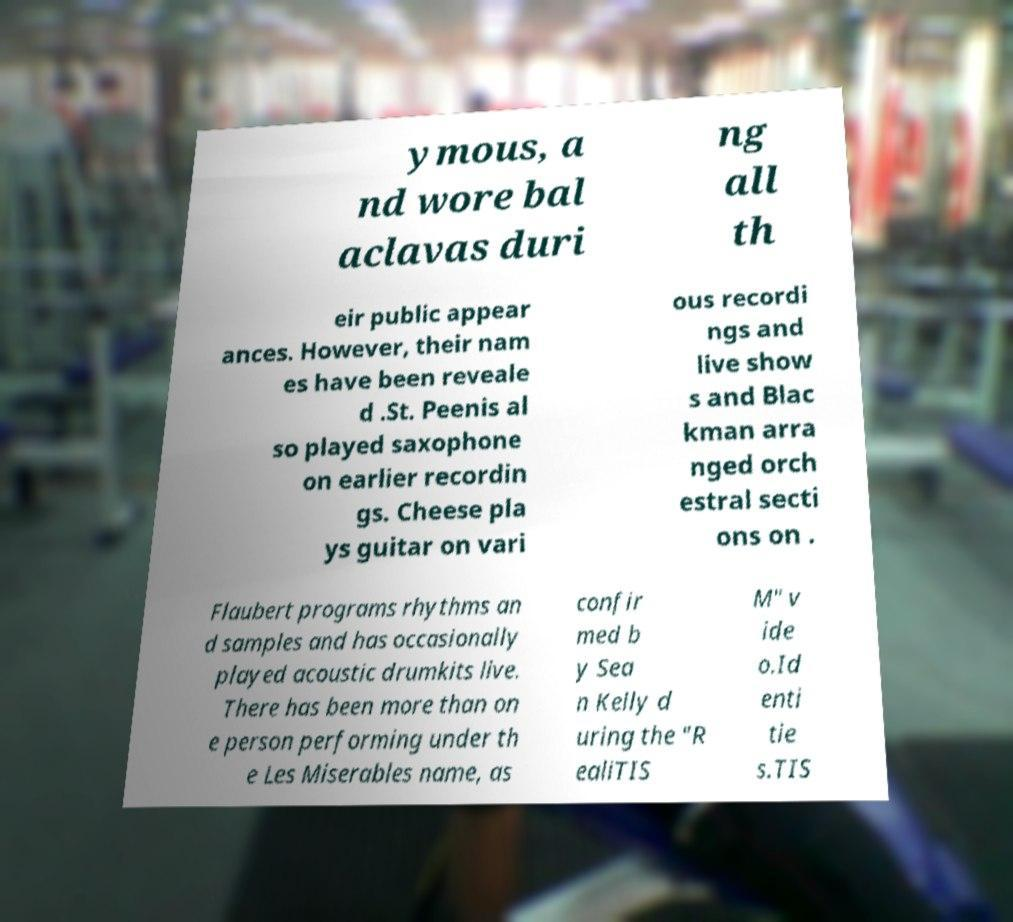What messages or text are displayed in this image? I need them in a readable, typed format. ymous, a nd wore bal aclavas duri ng all th eir public appear ances. However, their nam es have been reveale d .St. Peenis al so played saxophone on earlier recordin gs. Cheese pla ys guitar on vari ous recordi ngs and live show s and Blac kman arra nged orch estral secti ons on . Flaubert programs rhythms an d samples and has occasionally played acoustic drumkits live. There has been more than on e person performing under th e Les Miserables name, as confir med b y Sea n Kelly d uring the "R ealiTIS M" v ide o.Id enti tie s.TIS 